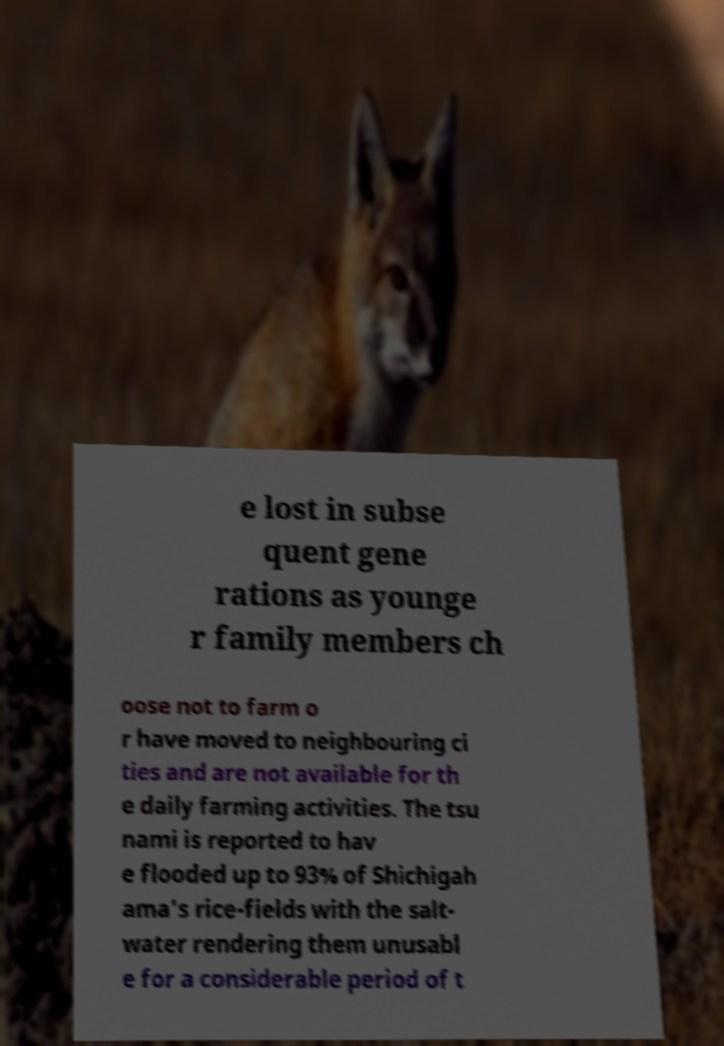What messages or text are displayed in this image? I need them in a readable, typed format. e lost in subse quent gene rations as younge r family members ch oose not to farm o r have moved to neighbouring ci ties and are not available for th e daily farming activities. The tsu nami is reported to hav e flooded up to 93% of Shichigah ama's rice-fields with the salt- water rendering them unusabl e for a considerable period of t 